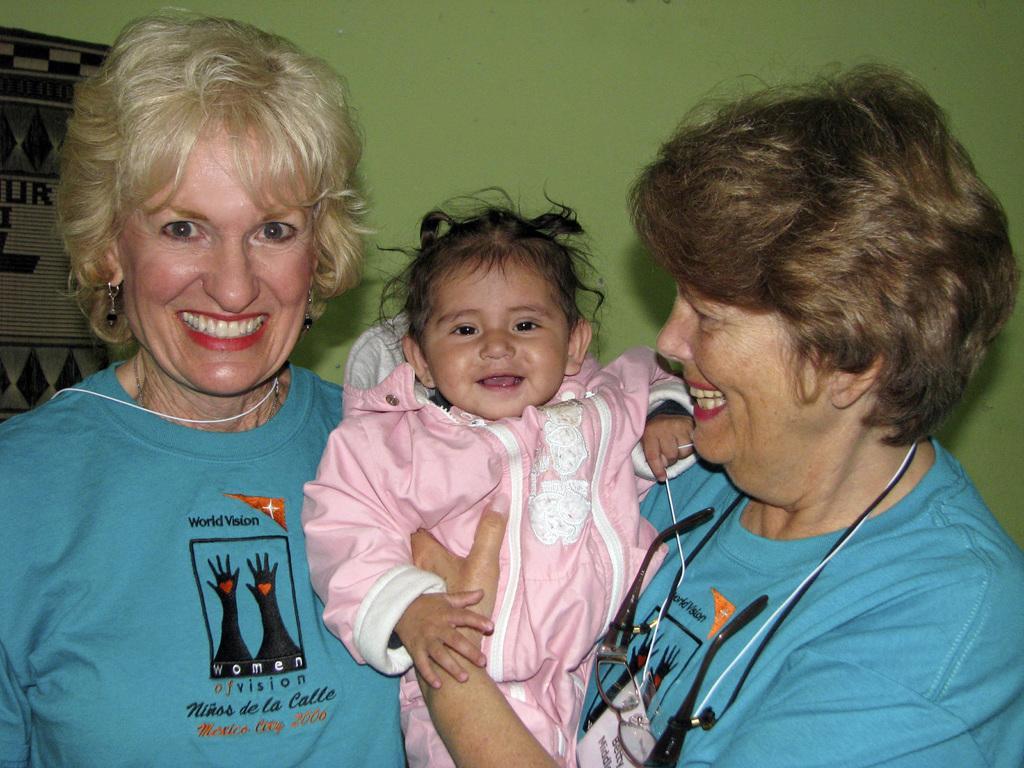Could you give a brief overview of what you see in this image? In this image we can see two women with smiling faces standing, one baby with smiling face, one object on the left side of the image, one woman on the right side of the image holding a baby, some text and images on the women's T-shirts. There is a green wall in the background. 